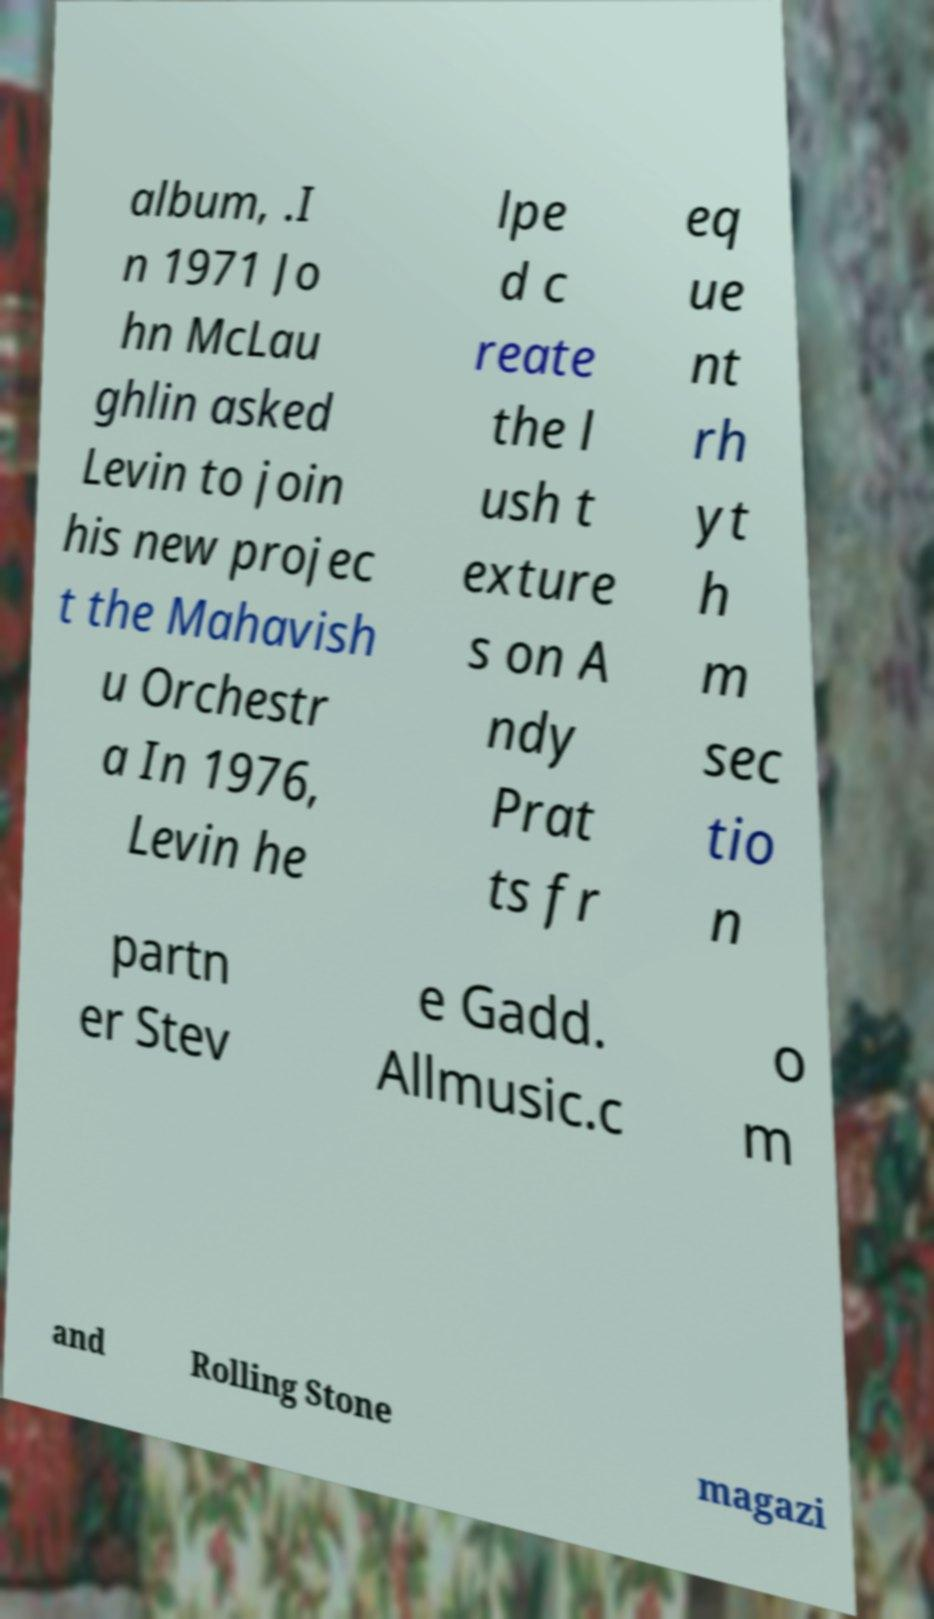Please identify and transcribe the text found in this image. album, .I n 1971 Jo hn McLau ghlin asked Levin to join his new projec t the Mahavish u Orchestr a In 1976, Levin he lpe d c reate the l ush t exture s on A ndy Prat ts fr eq ue nt rh yt h m sec tio n partn er Stev e Gadd. Allmusic.c o m and Rolling Stone magazi 